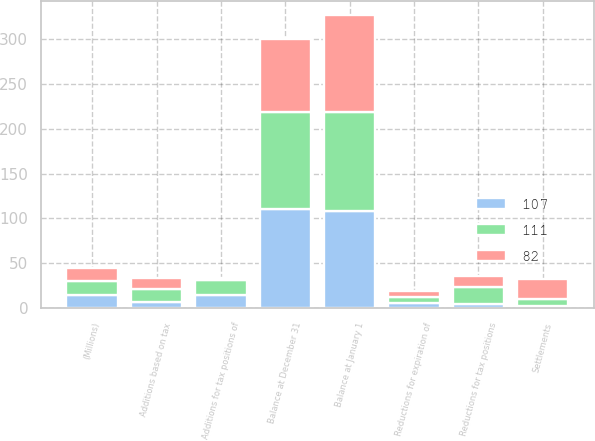<chart> <loc_0><loc_0><loc_500><loc_500><stacked_bar_chart><ecel><fcel>(Millions)<fcel>Balance at January 1<fcel>Additions based on tax<fcel>Additions for tax positions of<fcel>Reductions for tax positions<fcel>Reductions for expiration of<fcel>Settlements<fcel>Balance at December 31<nl><fcel>82<fcel>15<fcel>107<fcel>12<fcel>2<fcel>12<fcel>6<fcel>23<fcel>82<nl><fcel>111<fcel>15<fcel>111<fcel>15<fcel>17<fcel>19<fcel>7<fcel>8<fcel>107<nl><fcel>107<fcel>15<fcel>108<fcel>7<fcel>15<fcel>5<fcel>6<fcel>2<fcel>111<nl></chart> 